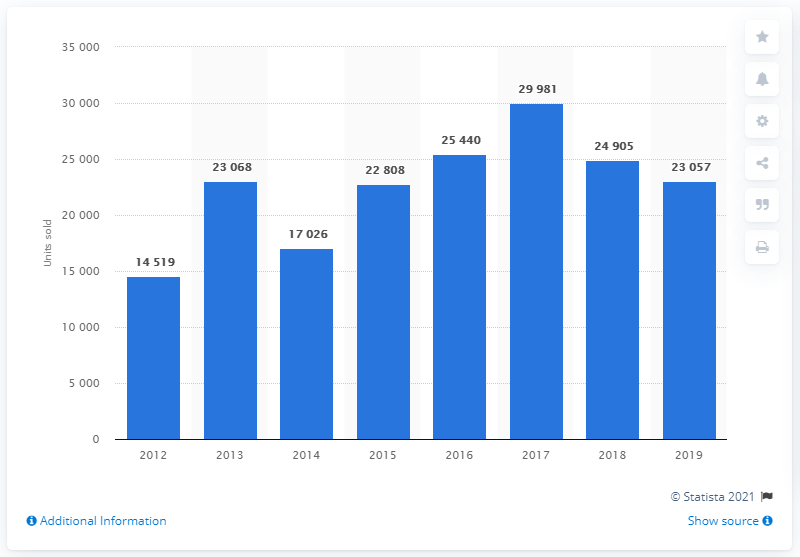Point out several critical features in this image. In 2019, Peugeot sold a total of 23,057 cars in Turkey. In 2017, Peugeot sold the highest number of cars in Turkey with 29,981 units. 